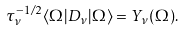Convert formula to latex. <formula><loc_0><loc_0><loc_500><loc_500>\tau _ { \nu } ^ { - 1 / 2 } \langle \Omega | D _ { \nu } | \Omega \rangle = Y _ { \nu } ( \Omega ) .</formula> 